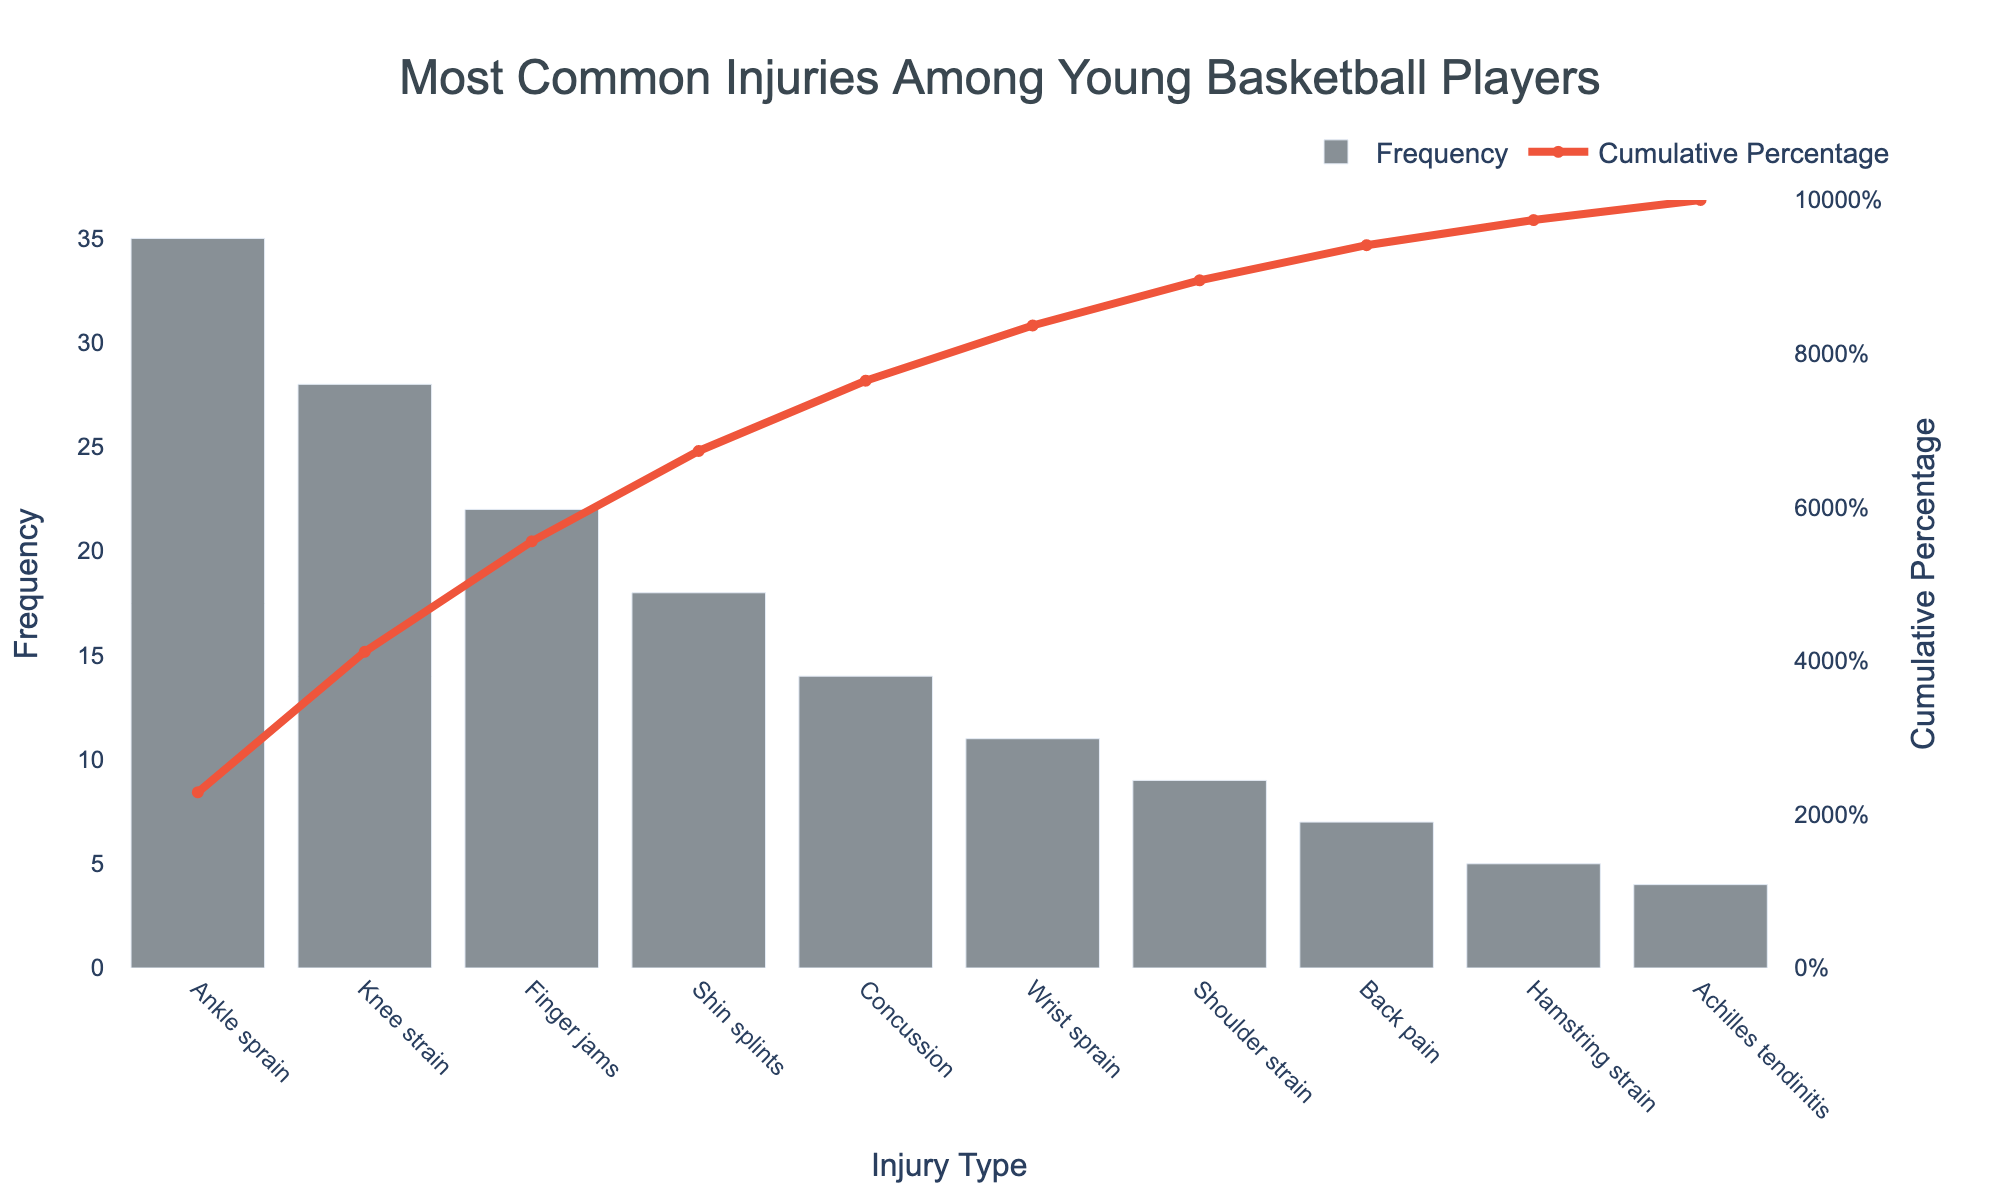What's the most common injury among young basketball players? The Pareto chart shows different injury types on the x-axis and their frequencies on the y-axis. The highest bar represents the most common injury.
Answer: Ankle sprain What is the cumulative percentage of injuries covered by the top two most common injuries? The top two injuries are "Ankle sprain" and "Knee strain." Add their frequencies (35 + 28 = 63). The total frequency of all injuries is 153. Calculate (63/153)*100 for percentage.
Answer: 41.2% Which injury ranks fourth in frequency? The injuries are ordered by frequency from highest to lowest. The fourth bar corresponds to shin splints.
Answer: Shin splints What's the total frequency of all recorded injuries? Sum all the given frequencies (35 + 28 + 22 + 18 + 14 + 11 + 9 + 7 + 5 + 4).
Answer: 153 What's the cumulative percentage after the top five injuries? The cumulative frequency of the top five injuries is the sum of their frequencies (35 + 28 + 22 + 18 + 14 = 117). The total frequency is 153. Calculate (117/153)*100.
Answer: 76.5% Which injury type has a frequency just below 10? Look at the bars and identify the injury with the frequency just below 10. This corresponds to the shoulder strain.
Answer: Shoulder strain How does the frequency of finger jams compare to wrist sprains? Find the bars for 'Finger jams' and 'Wrist sprains' and compare their heights. Finger jams have a higher frequency.
Answer: Finger jams are higher Around what percentage cumulative total does the injury 'Concussion' reach? Find the point where the 'Cumulative Percentage' line intersects 'Concussion' on the x-axis.
Answer: 77.1% What is the least common injury and its frequency? The shortest bar on the Pareto chart represents the least common injury. This corresponds to Achilles tendinitis.
Answer: Achilles tendinitis; 4 Which injuries combine to make up over 50% of all injuries? Look at the cumulative percentage line and identify the point where it crosses 50%. Count the injuries leading up to this point. The top three injuries (Ankle sprain, Knee strain, Finger jams) together make over 50%.
Answer: Ankle sprain, Knee strain, Finger jams 